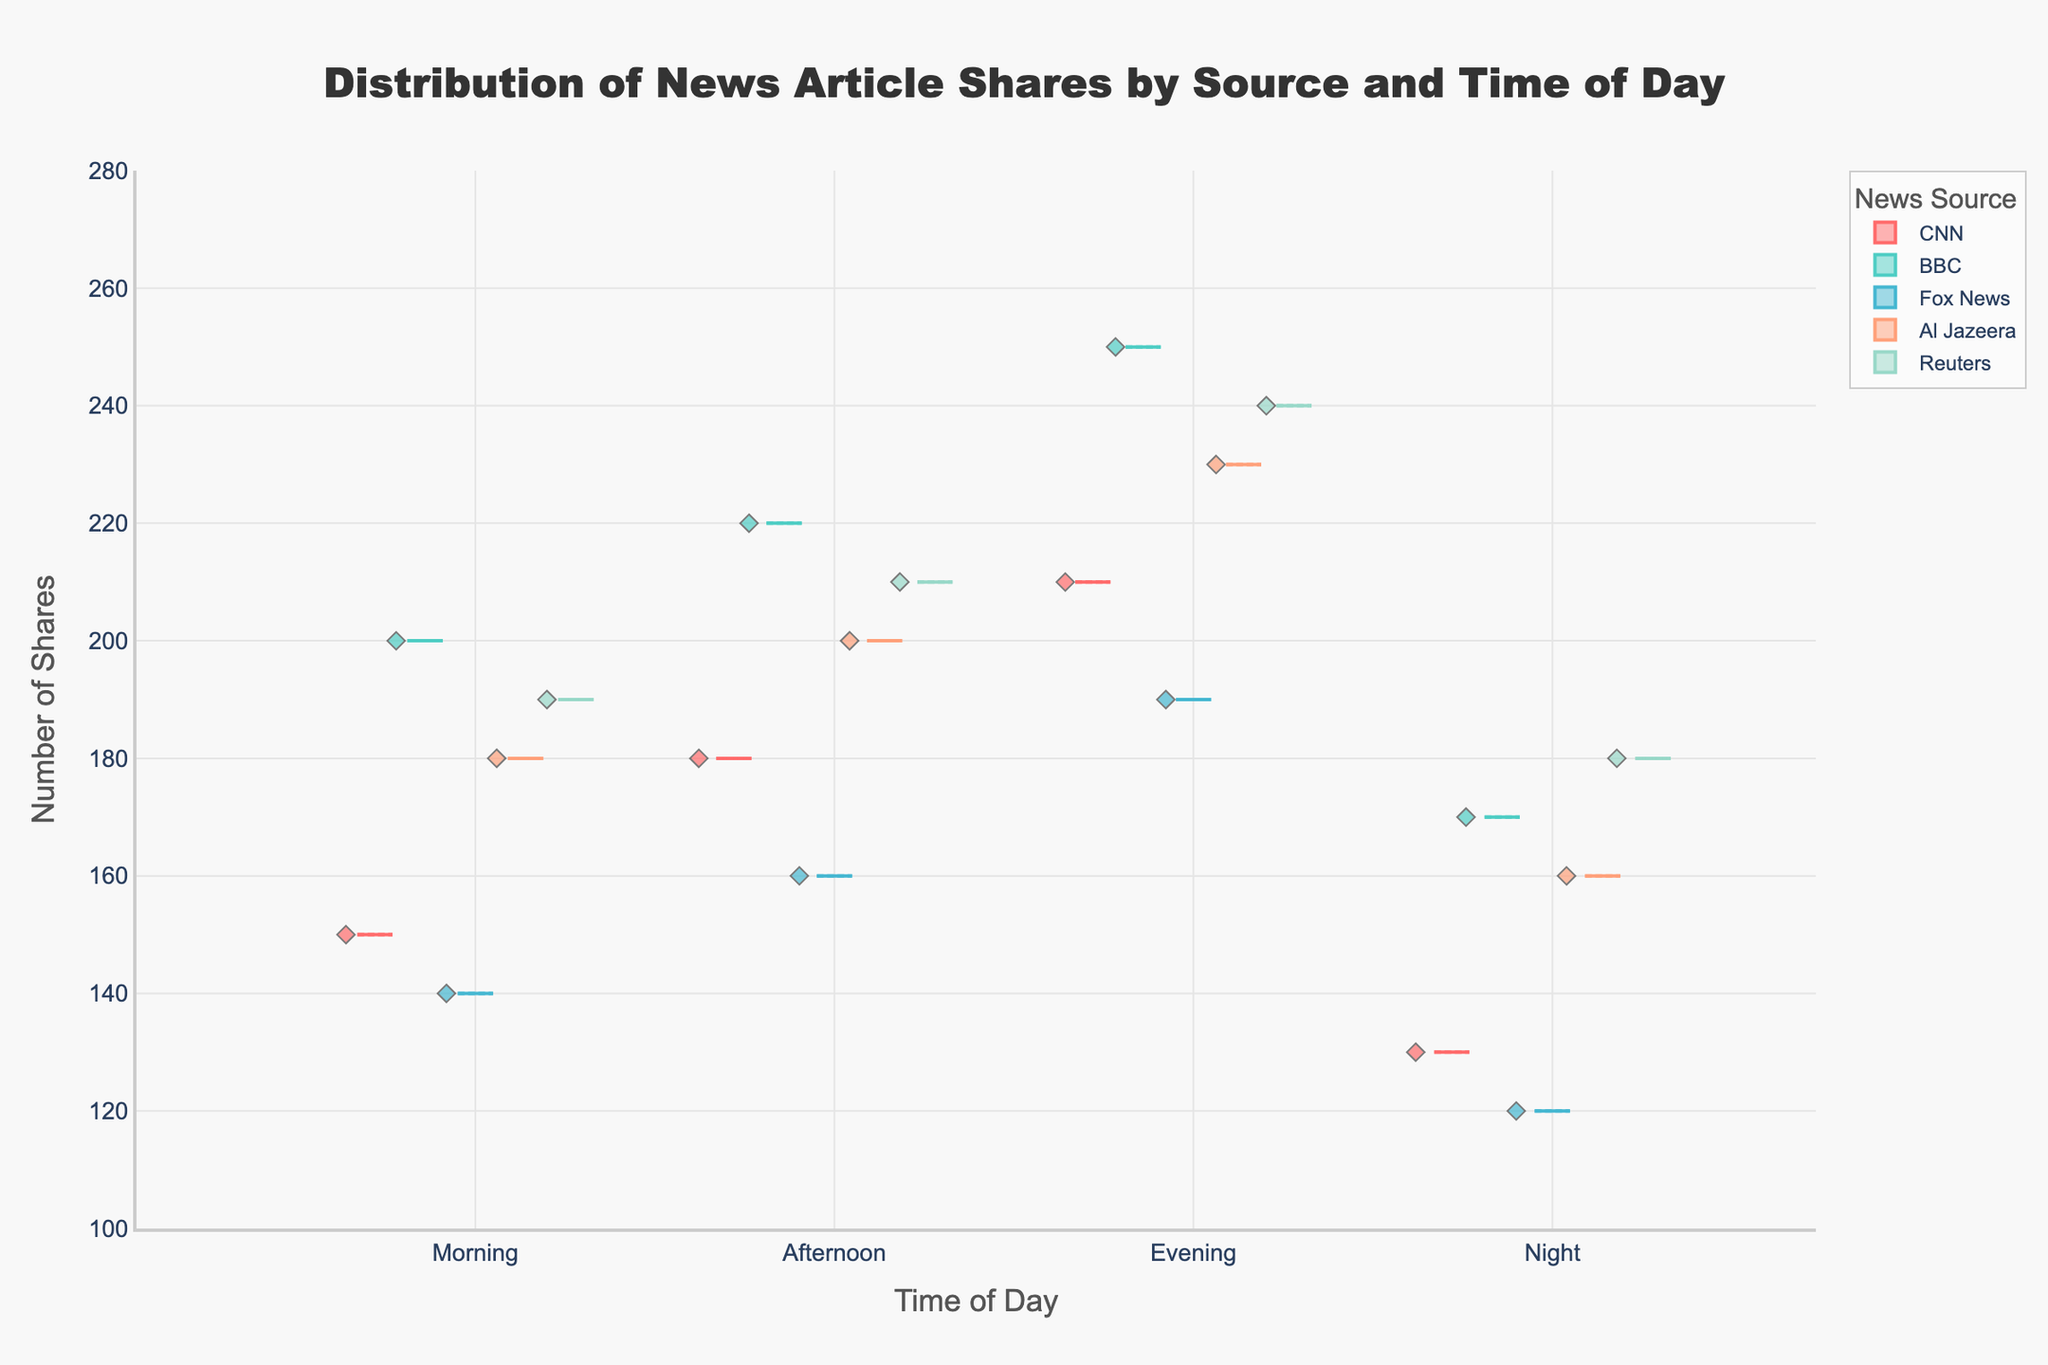What is the title of the figure? The title of the figure is always prominently displayed at the top of the chart. Here, it can easily be read.
Answer: Distribution of News Article Shares by Source and Time of Day How many news sources are included in the figure? Count the distinct news sources listed in the legend or on the x-axis.
Answer: 5 Which time of day has the highest median number of shares for Fox News? Look at the notched boxes for Fox News at each time of day and identify the one with the highest median line.
Answer: Evening What's the range of the y-axis in the figure? Check the y-axis from the lowest to the highest value indicated.
Answer: 100 to 280 Which news source has the widest interquartile range (IQR) in the Evening? Identify the boxes for each source in the Evening. The IQR is the length of the box, which is the distance between the lower quartile (bottom line of the box) and the upper quartile (top line of the box).
Answer: BBC What is the range of shares for CNN in the Morning? Check the bottom and top whiskers of the box for CNN in the Morning to find the range.
Answer: 130 to 150 Which news source has the highest median number of shares in the Afternoon? Look for the news source with the highest position of the median line within the boxes labeled "Afternoon".
Answer: BBC Is there any time of day where CNN has outliers in shares? Look for individual points outside the whiskers in the boxes for CNN across different times of day.
Answer: No How does the distribution of Reuters shares at Night compare to that of Al Jazeera at Night? Compare the boxes for Reuters and Al Jazeera at "Night" in terms of median, IQR, and overall range. Additionally, look for outliers and shape of the distribution.
Answer: Reuters has a higher median, but Al Jazeera has a wider distribution Which news source has the most consistent number of shares throughout the day? Consistency can be assessed by looking at which source has the smallest variation across all times of day, evident by the shortest boxes and whiskers.
Answer: Fox News 